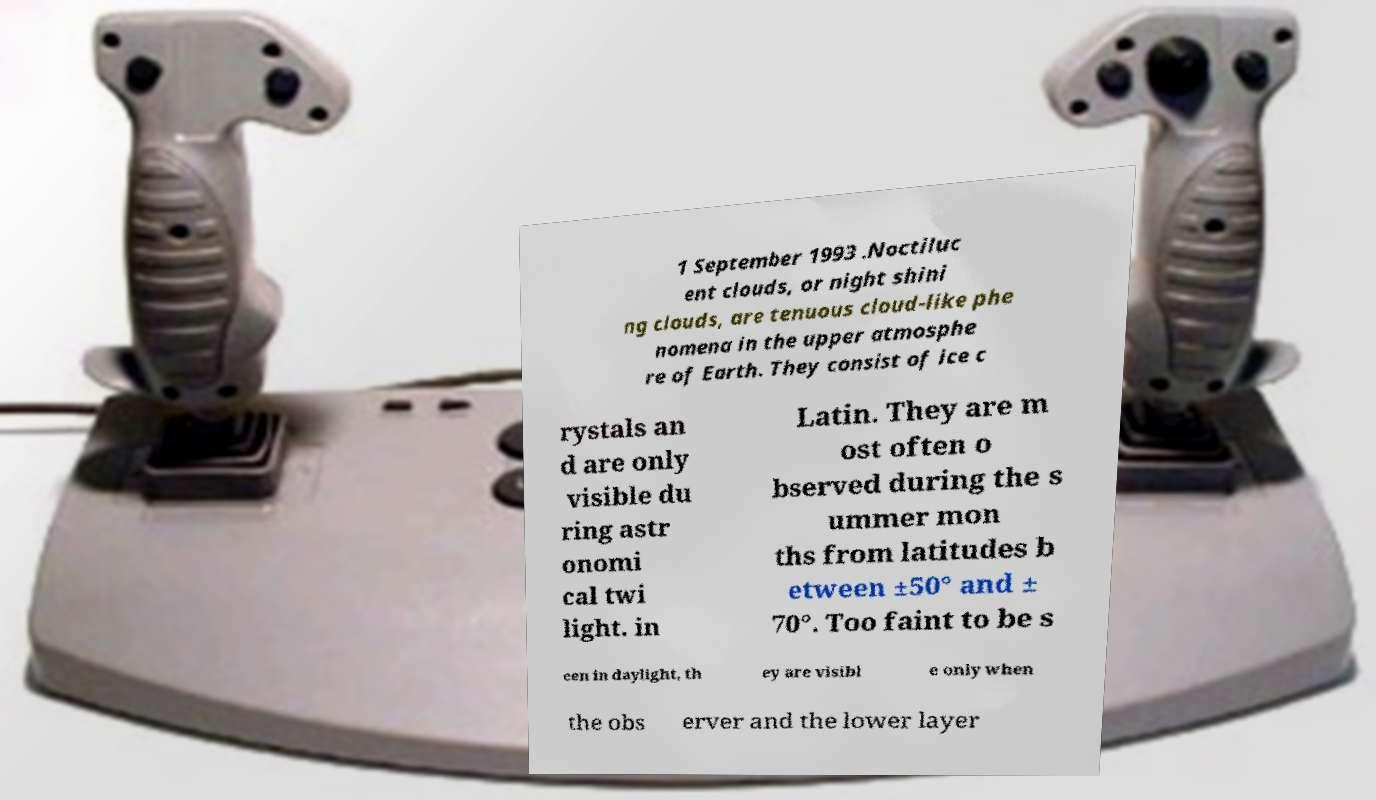Please read and relay the text visible in this image. What does it say? 1 September 1993 .Noctiluc ent clouds, or night shini ng clouds, are tenuous cloud-like phe nomena in the upper atmosphe re of Earth. They consist of ice c rystals an d are only visible du ring astr onomi cal twi light. in Latin. They are m ost often o bserved during the s ummer mon ths from latitudes b etween ±50° and ± 70°. Too faint to be s een in daylight, th ey are visibl e only when the obs erver and the lower layer 